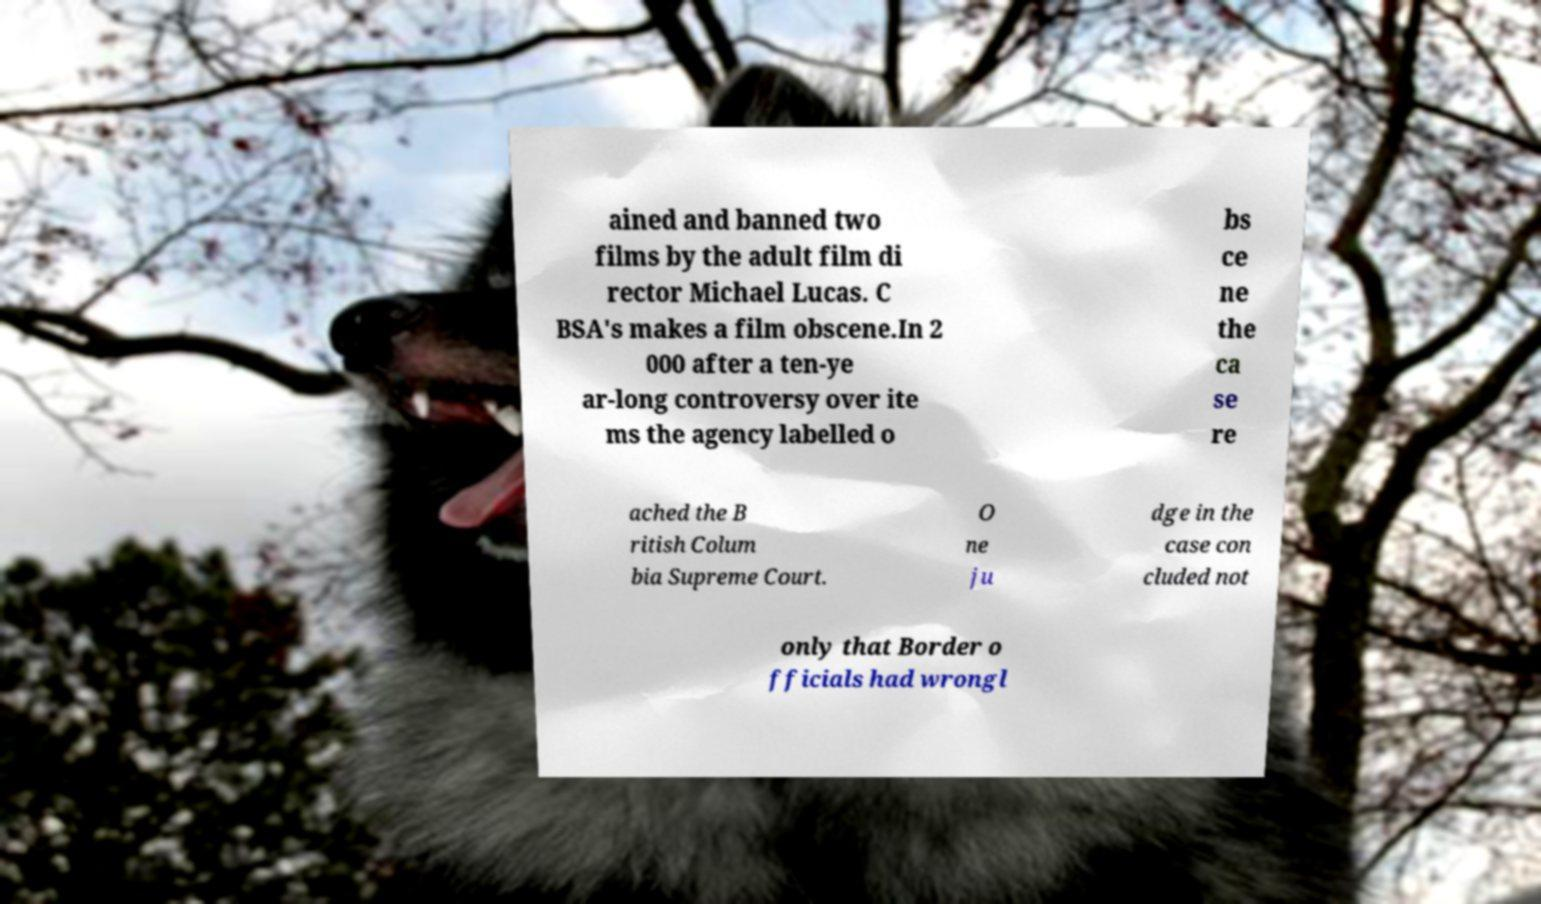Please read and relay the text visible in this image. What does it say? ained and banned two films by the adult film di rector Michael Lucas. C BSA's makes a film obscene.In 2 000 after a ten-ye ar-long controversy over ite ms the agency labelled o bs ce ne the ca se re ached the B ritish Colum bia Supreme Court. O ne ju dge in the case con cluded not only that Border o fficials had wrongl 